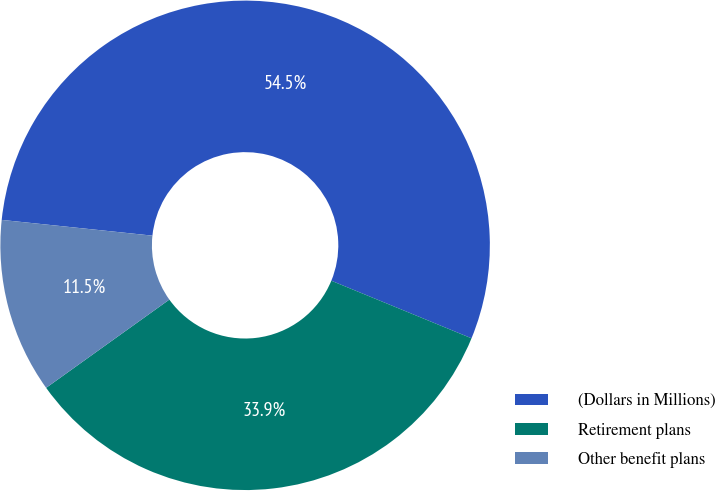<chart> <loc_0><loc_0><loc_500><loc_500><pie_chart><fcel>(Dollars in Millions)<fcel>Retirement plans<fcel>Other benefit plans<nl><fcel>54.55%<fcel>33.91%<fcel>11.55%<nl></chart> 